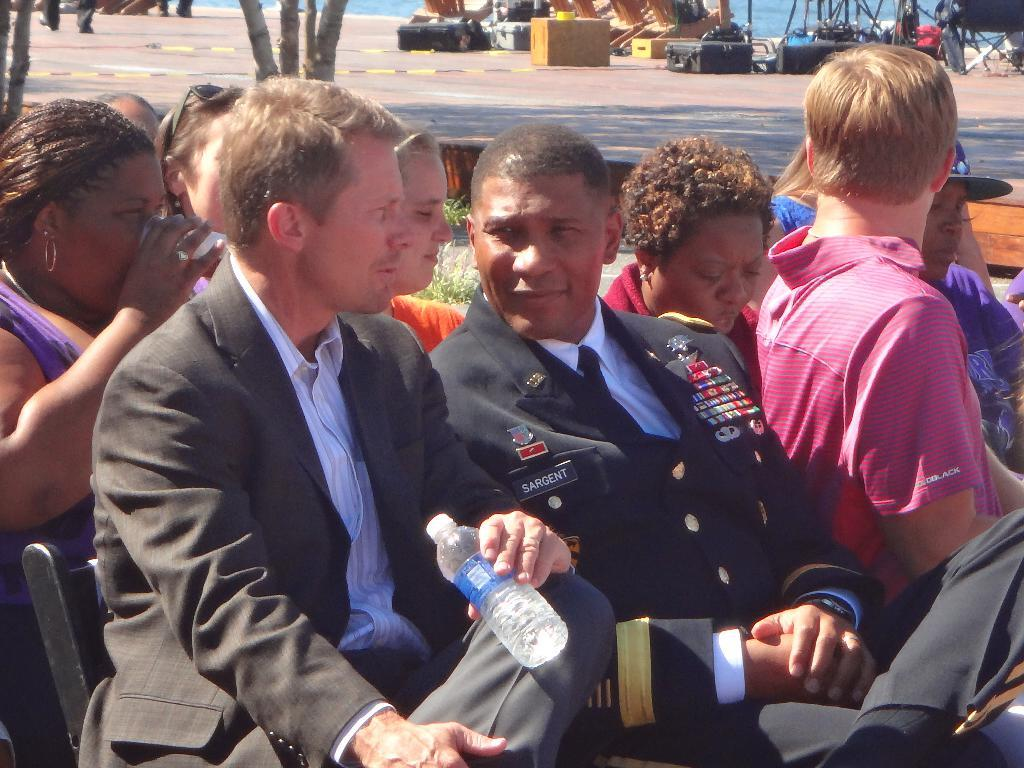What are the people in the image doing? The people in the image are sitting on chairs. What can be seen in the distance behind the people? There are trees and a road visible in the background of the image. What is on the road in the image? There are objects on the road. What else can be seen in the background of the image? There is water visible in the background of the image. Can you tell me where the nest is located in the image? There is no nest present in the image. What type of prison can be seen in the image? There is no prison present in the image. 